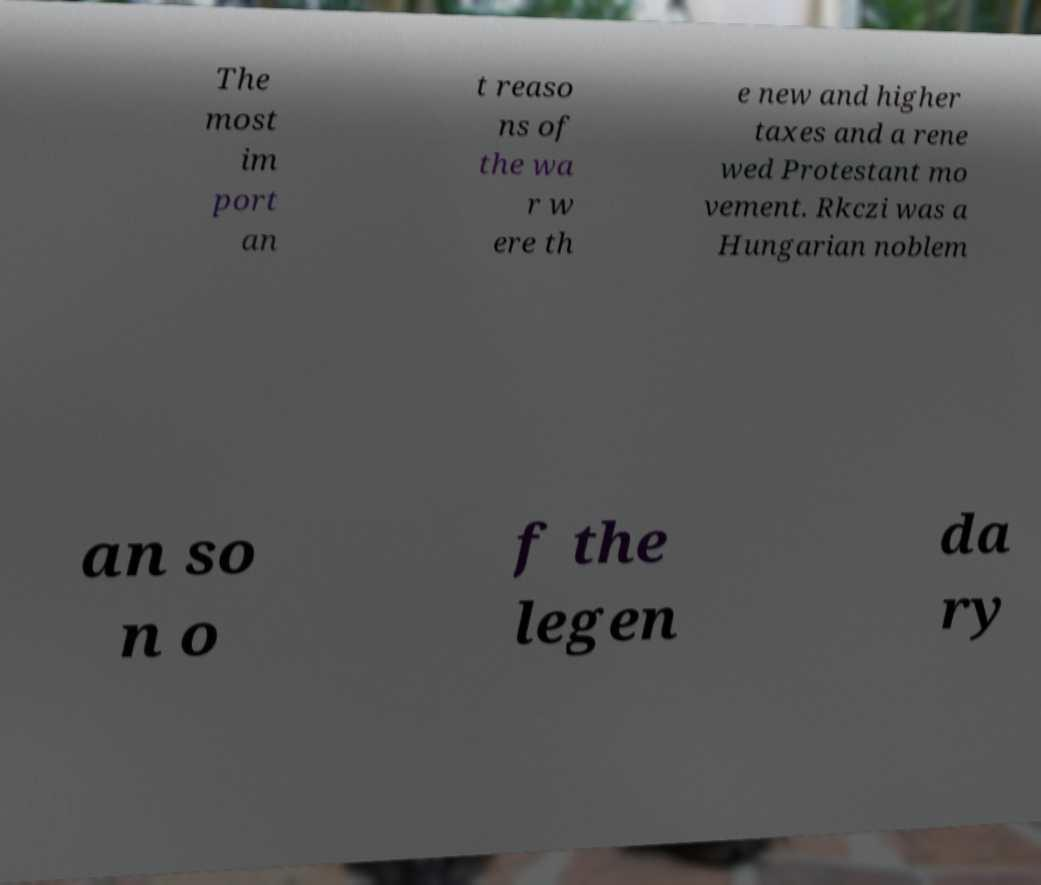Can you accurately transcribe the text from the provided image for me? The most im port an t reaso ns of the wa r w ere th e new and higher taxes and a rene wed Protestant mo vement. Rkczi was a Hungarian noblem an so n o f the legen da ry 